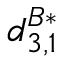<formula> <loc_0><loc_0><loc_500><loc_500>d _ { 3 , 1 } ^ { B * }</formula> 